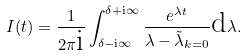Convert formula to latex. <formula><loc_0><loc_0><loc_500><loc_500>I ( t ) = \frac { 1 } { 2 \pi \text {i} } \int _ { \delta - \text {i} \infty } ^ { \delta + \text {i} \infty } \frac { e ^ { \lambda t } } { \lambda - \tilde { \lambda } _ { { k } = 0 } } \text {d} \lambda .</formula> 